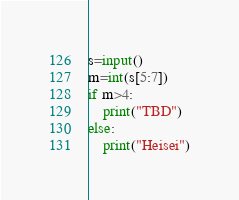<code> <loc_0><loc_0><loc_500><loc_500><_Python_>s=input()
m=int(s[5:7])
if m>4:
	print("TBD")
else:
	print("Heisei")</code> 